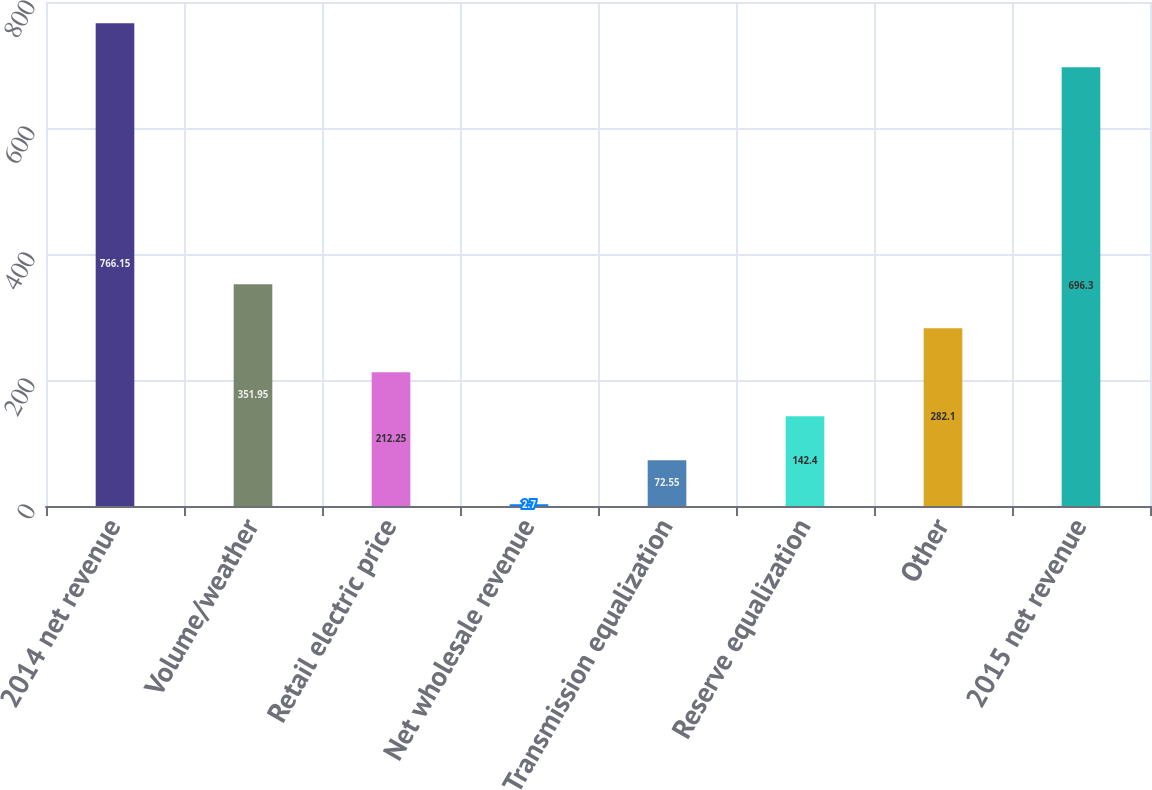Convert chart to OTSL. <chart><loc_0><loc_0><loc_500><loc_500><bar_chart><fcel>2014 net revenue<fcel>Volume/weather<fcel>Retail electric price<fcel>Net wholesale revenue<fcel>Transmission equalization<fcel>Reserve equalization<fcel>Other<fcel>2015 net revenue<nl><fcel>766.15<fcel>351.95<fcel>212.25<fcel>2.7<fcel>72.55<fcel>142.4<fcel>282.1<fcel>696.3<nl></chart> 